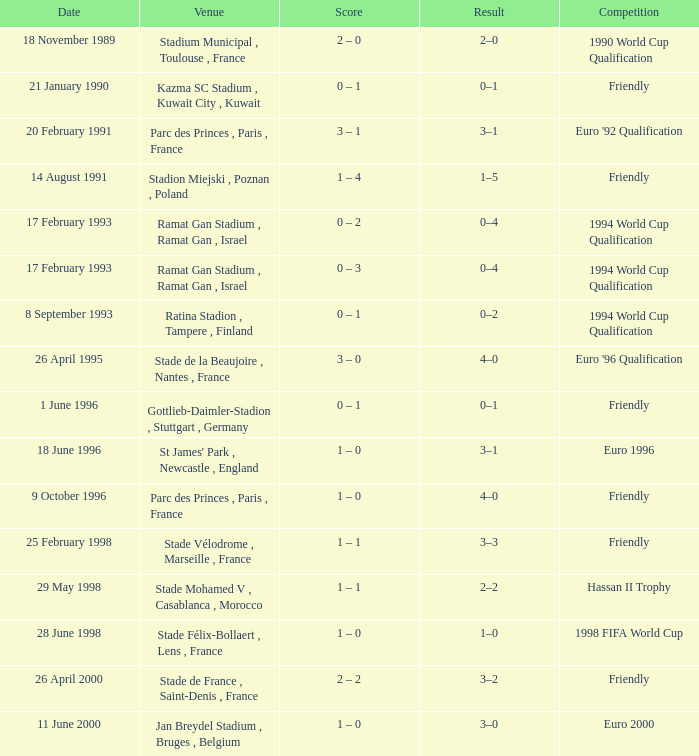What was the date of the game with a result of 3–2? 26 April 2000. 